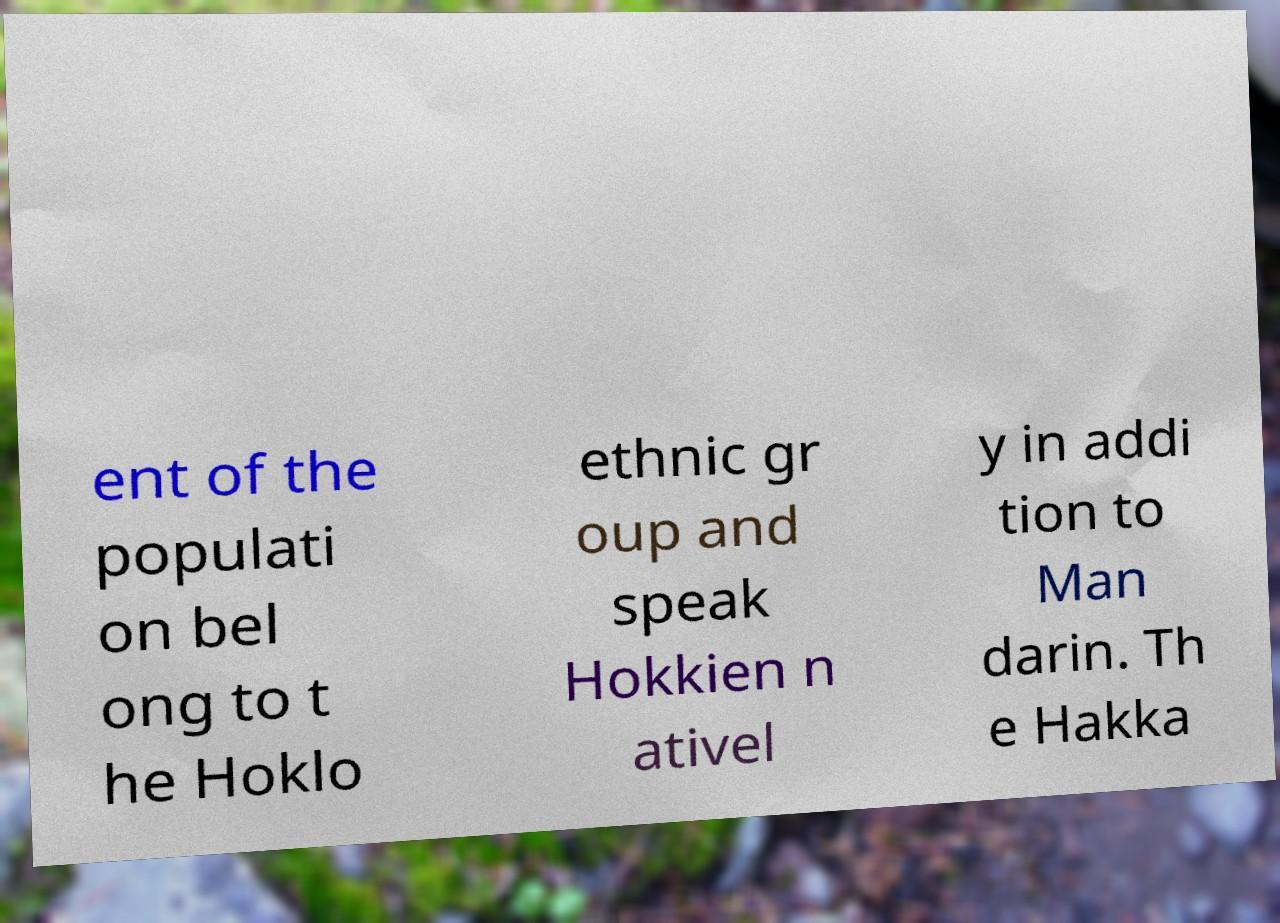I need the written content from this picture converted into text. Can you do that? ent of the populati on bel ong to t he Hoklo ethnic gr oup and speak Hokkien n ativel y in addi tion to Man darin. Th e Hakka 